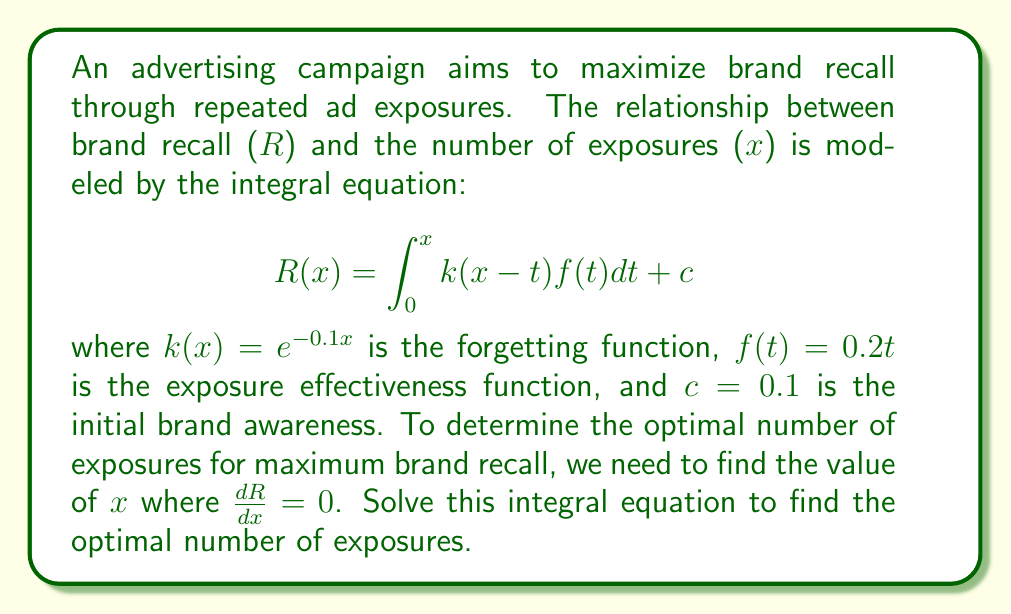Show me your answer to this math problem. To solve this problem, we'll follow these steps:

1) First, we need to calculate R(x) by solving the integral equation:

   $$R(x) = \int_0^x e^{-0.1(x-t)}(0.2t)dt + 0.1$$

2) Using integration by parts, we can solve this integral:

   $$\begin{align}
   R(x) &= 0.2\left[-10e^{-0.1(x-t)}t\right]_0^x + 0.2\int_0^x 10e^{-0.1(x-t)}dt + 0.1 \\
   &= -2xe^0 + 0.2\left[-100e^{-0.1(x-t)}\right]_0^x + 0.1 \\
   &= -2x - 20e^{-0.1x} + 20 + 0.1
   \end{align}$$

3) Now we have R(x) in terms of x:

   $$R(x) = -2x - 20e^{-0.1x} + 20.1$$

4) To find the maximum, we need to differentiate R(x) and set it to zero:

   $$\frac{dR}{dx} = -2 + 2e^{-0.1x} = 0$$

5) Solving this equation:

   $$2e^{-0.1x} = 2$$
   $$e^{-0.1x} = 1$$
   $$-0.1x = 0$$
   $$x = 0$$

6) However, x = 0 gives a minimum, not a maximum. The function R(x) actually has no maximum, as it decreases after an initial increase.

7) To find the "optimal" number of exposures, we should instead look for the point where the rate of decrease becomes significant. This is often taken as the point where the second derivative equals zero.

8) The second derivative is:

   $$\frac{d^2R}{dx^2} = -0.2e^{-0.1x}$$

9) Setting this to zero:

   $$-0.2e^{-0.1x} = 0$$

   This equation has no solution, confirming that R(x) has no inflection point.

10) In practice, we might choose a point where the rate of change is small, say where $\frac{dR}{dx} = -0.1$:

    $$-2 + 2e^{-0.1x} = -0.1$$
    $$2e^{-0.1x} = 1.9$$
    $$e^{-0.1x} = 0.95$$
    $$-0.1x = \ln(0.95)$$
    $$x = -10\ln(0.95) \approx 0.513$$

Therefore, the optimal number of exposures is approximately 0.513, or rounded up to 1 exposure.
Answer: 1 exposure 